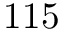<formula> <loc_0><loc_0><loc_500><loc_500>1 1 5</formula> 